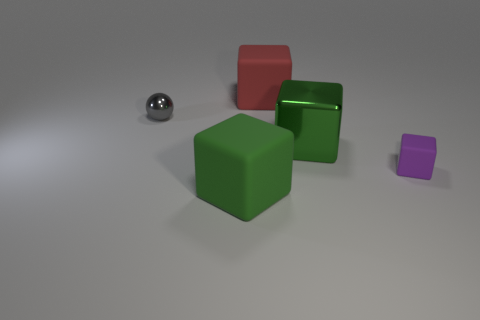Subtract 2 blocks. How many blocks are left? 2 Subtract all red cubes. How many cubes are left? 3 Subtract all small matte blocks. How many blocks are left? 3 Add 5 big blue matte things. How many objects exist? 10 Subtract all brown blocks. Subtract all red spheres. How many blocks are left? 4 Subtract all spheres. How many objects are left? 4 Add 4 red rubber things. How many red rubber things are left? 5 Add 2 green cubes. How many green cubes exist? 4 Subtract 0 cyan cubes. How many objects are left? 5 Subtract all tiny gray objects. Subtract all large purple metal balls. How many objects are left? 4 